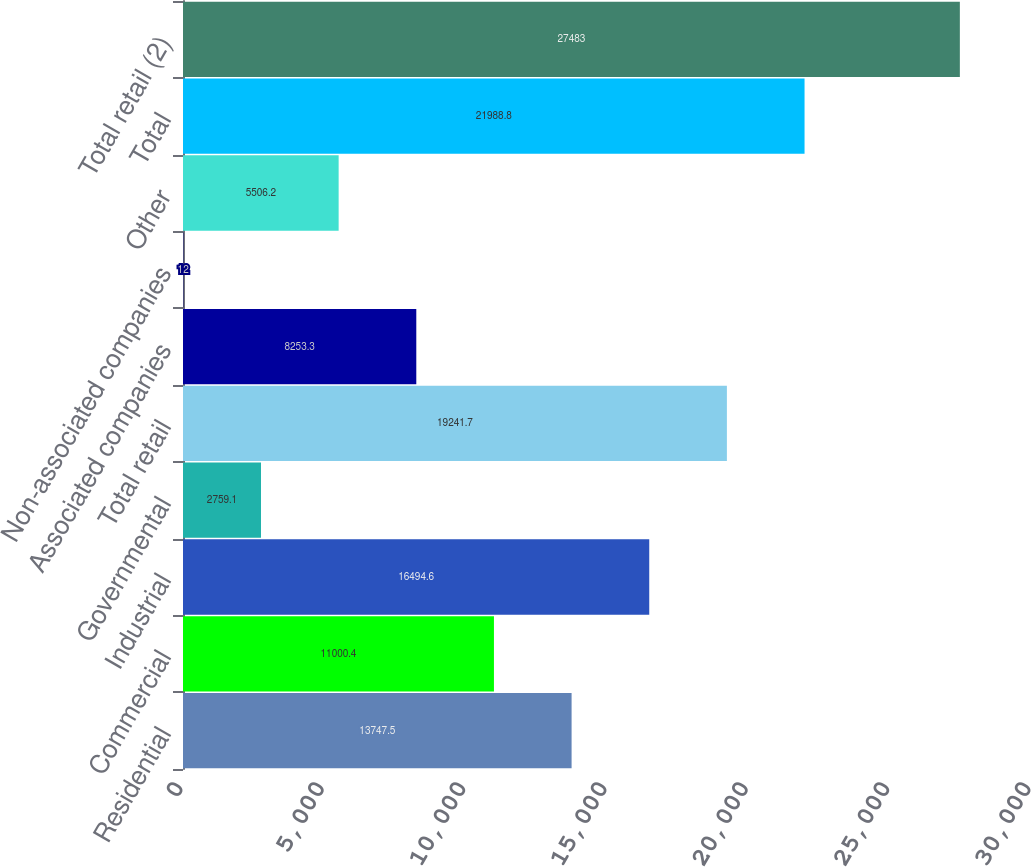<chart> <loc_0><loc_0><loc_500><loc_500><bar_chart><fcel>Residential<fcel>Commercial<fcel>Industrial<fcel>Governmental<fcel>Total retail<fcel>Associated companies<fcel>Non-associated companies<fcel>Other<fcel>Total<fcel>Total retail (2)<nl><fcel>13747.5<fcel>11000.4<fcel>16494.6<fcel>2759.1<fcel>19241.7<fcel>8253.3<fcel>12<fcel>5506.2<fcel>21988.8<fcel>27483<nl></chart> 